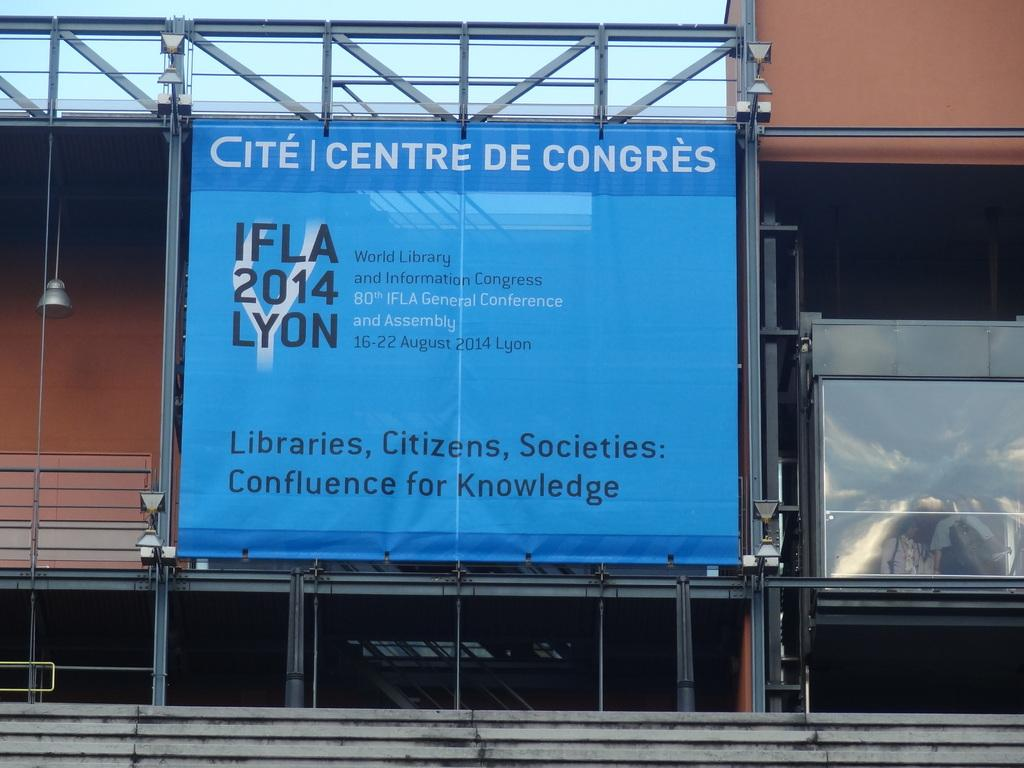<image>
Write a terse but informative summary of the picture. A blue sign hanging sponsoring IFLA 2014 LYON. 